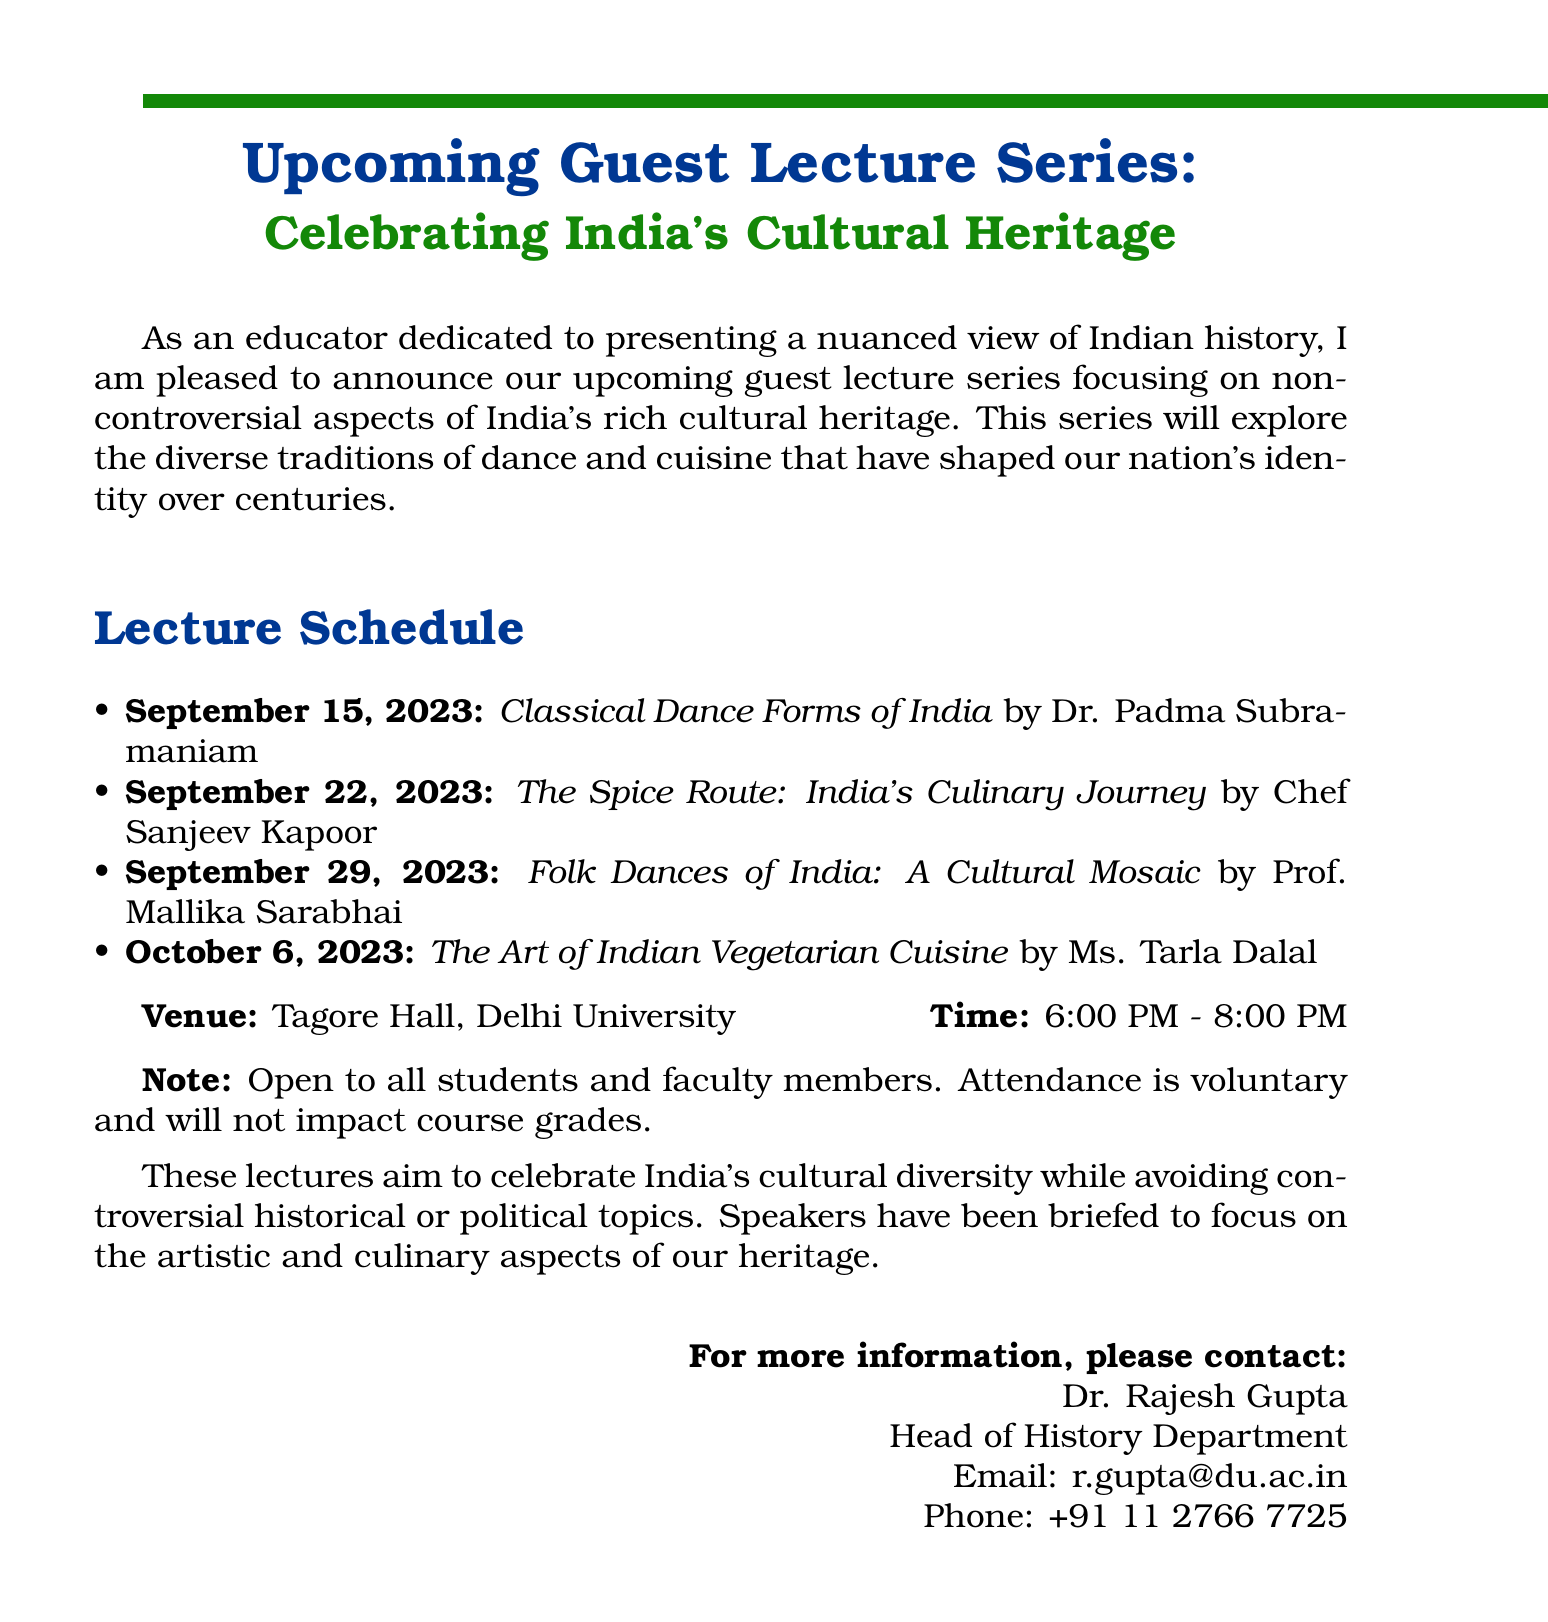What is the title of the memo? The title of the memo introduces the guest lecture series and highlights its cultural focus.
Answer: Upcoming Guest Lecture Series: Celebrating India's Cultural Heritage Who is the speaker for the lecture on classical dance forms? This question identifies the speaker for the first lecture mentioned in the schedule.
Answer: Dr. Padma Subramaniam What date is the lecture on Indian vegetarian cuisine scheduled for? The question asks for the specific date associated with the fourth lecture.
Answer: October 6, 2023 What is the venue for the lecture series? This question seeks information regarding the location where the lectures will take place.
Answer: Tagore Hall, Delhi University What time do the lectures start? This question focuses on the starting time of the lecture series as indicated in the document.
Answer: 6:00 PM How many lectures are there in total? The question requires counting the number of distinct lectures listed in the schedule section.
Answer: 4 What is the main focus of the guest lecture series? This question examines the primary theme of the series as stated in the introduction paragraph.
Answer: Non-controversial aspects of India's cultural heritage Are the lectures mandatory for students? The question pertains to the attendance policy stated in the audience note.
Answer: No Who should be contacted for more information? This question looks for the designated contact person mentioned at the end of the memo.
Answer: Dr. Rajesh Gupta 